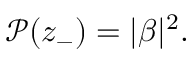<formula> <loc_0><loc_0><loc_500><loc_500>\mathcal { P } ( z _ { - } ) = | \beta | ^ { 2 } .</formula> 